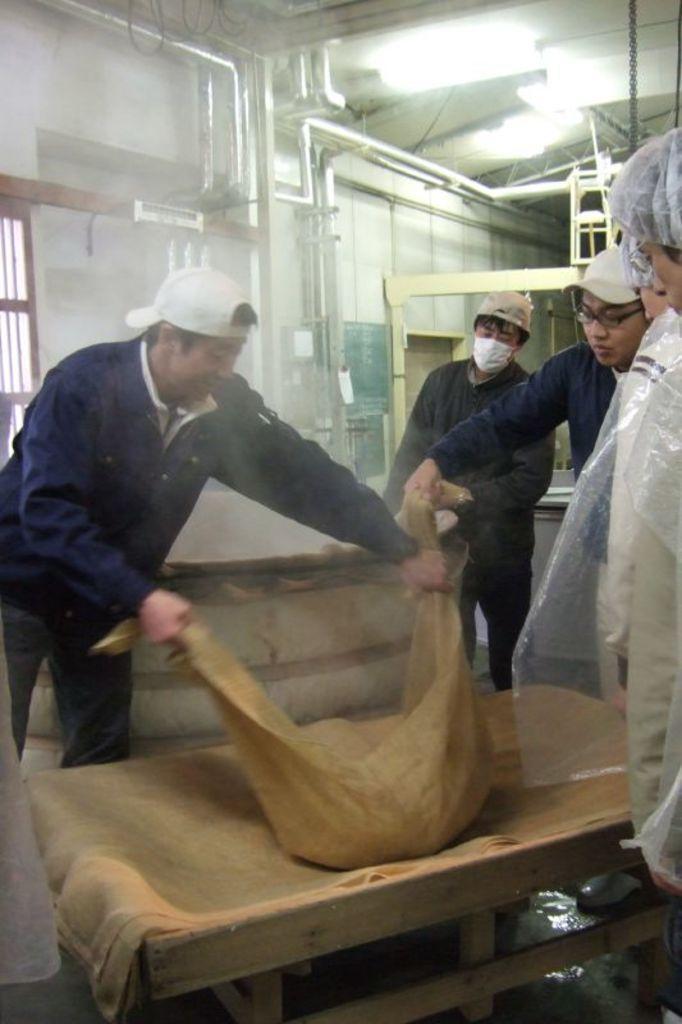Please provide a concise description of this image. In this picture we can see there are two people holding an item and other people standing on the path. In front of the people there is a wooden object. Behind the people there is smoke, a wall with pipes and a board. 